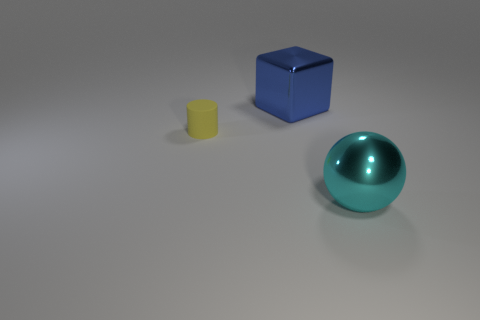Add 3 tiny red matte things. How many objects exist? 6 Subtract all cubes. How many objects are left? 2 Subtract all tiny yellow cylinders. Subtract all metallic balls. How many objects are left? 1 Add 3 big metal balls. How many big metal balls are left? 4 Add 2 large metal spheres. How many large metal spheres exist? 3 Subtract 0 blue spheres. How many objects are left? 3 